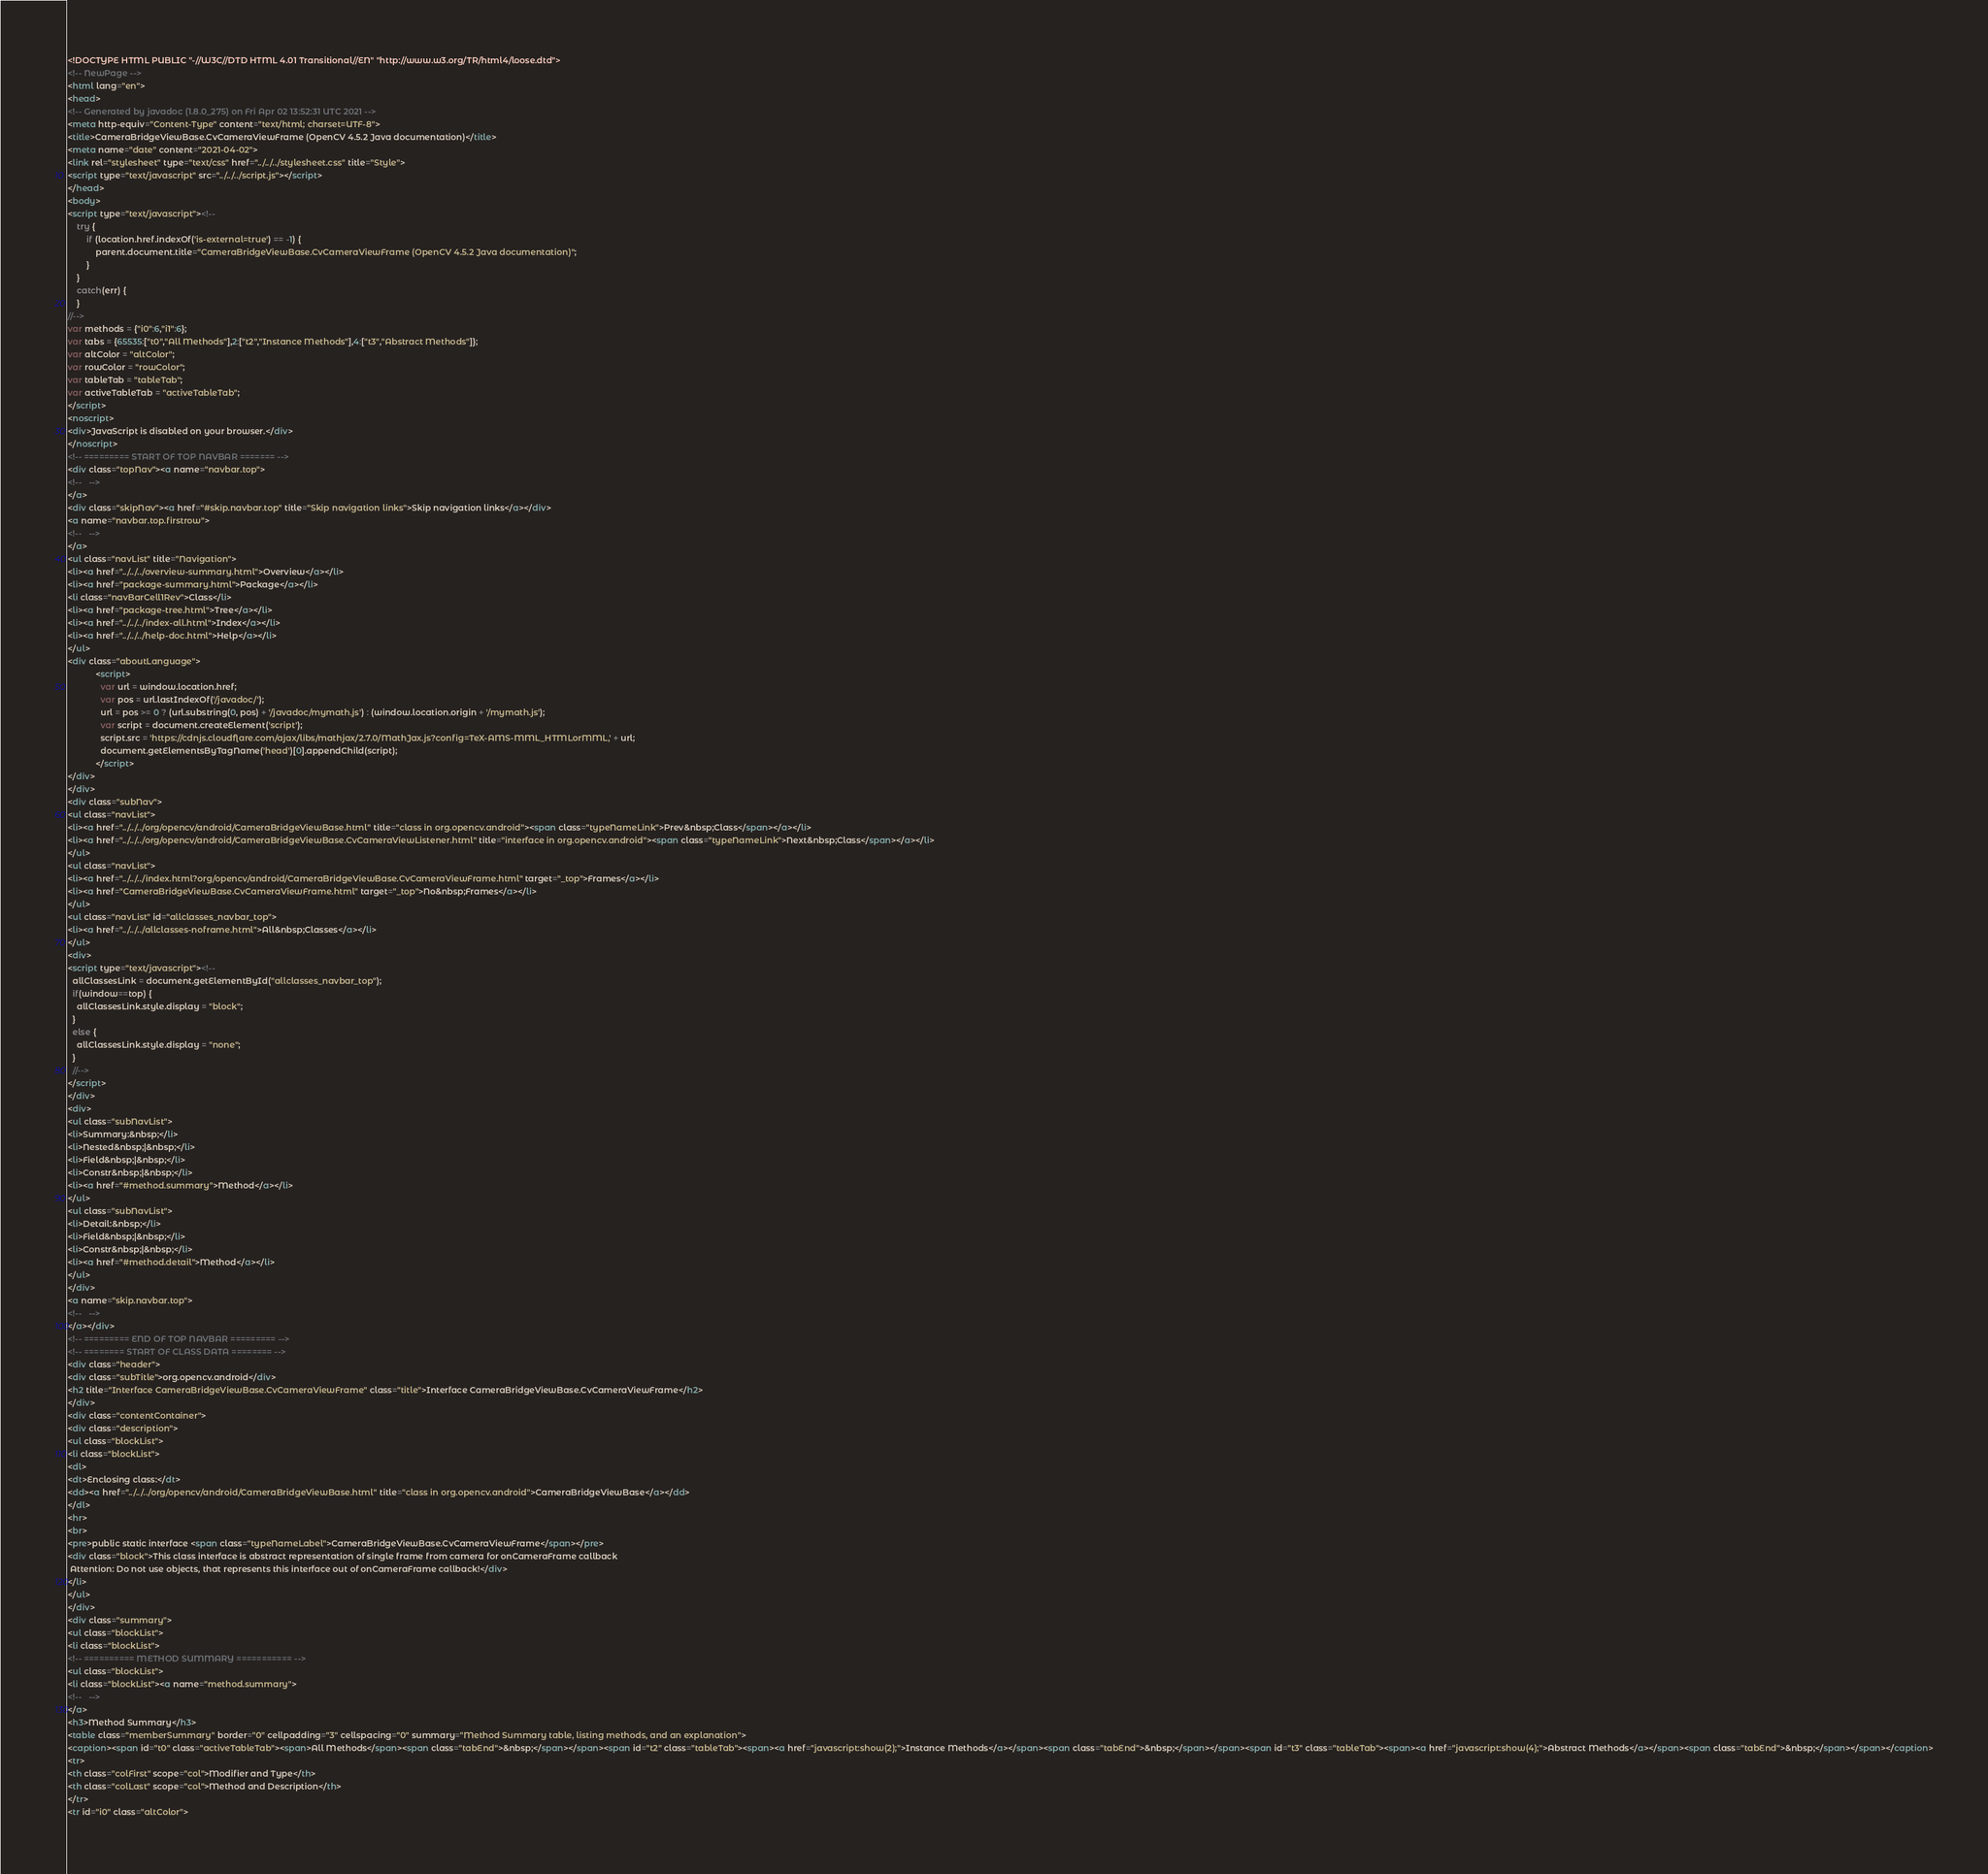<code> <loc_0><loc_0><loc_500><loc_500><_HTML_><!DOCTYPE HTML PUBLIC "-//W3C//DTD HTML 4.01 Transitional//EN" "http://www.w3.org/TR/html4/loose.dtd">
<!-- NewPage -->
<html lang="en">
<head>
<!-- Generated by javadoc (1.8.0_275) on Fri Apr 02 13:52:31 UTC 2021 -->
<meta http-equiv="Content-Type" content="text/html; charset=UTF-8">
<title>CameraBridgeViewBase.CvCameraViewFrame (OpenCV 4.5.2 Java documentation)</title>
<meta name="date" content="2021-04-02">
<link rel="stylesheet" type="text/css" href="../../../stylesheet.css" title="Style">
<script type="text/javascript" src="../../../script.js"></script>
</head>
<body>
<script type="text/javascript"><!--
    try {
        if (location.href.indexOf('is-external=true') == -1) {
            parent.document.title="CameraBridgeViewBase.CvCameraViewFrame (OpenCV 4.5.2 Java documentation)";
        }
    }
    catch(err) {
    }
//-->
var methods = {"i0":6,"i1":6};
var tabs = {65535:["t0","All Methods"],2:["t2","Instance Methods"],4:["t3","Abstract Methods"]};
var altColor = "altColor";
var rowColor = "rowColor";
var tableTab = "tableTab";
var activeTableTab = "activeTableTab";
</script>
<noscript>
<div>JavaScript is disabled on your browser.</div>
</noscript>
<!-- ========= START OF TOP NAVBAR ======= -->
<div class="topNav"><a name="navbar.top">
<!--   -->
</a>
<div class="skipNav"><a href="#skip.navbar.top" title="Skip navigation links">Skip navigation links</a></div>
<a name="navbar.top.firstrow">
<!--   -->
</a>
<ul class="navList" title="Navigation">
<li><a href="../../../overview-summary.html">Overview</a></li>
<li><a href="package-summary.html">Package</a></li>
<li class="navBarCell1Rev">Class</li>
<li><a href="package-tree.html">Tree</a></li>
<li><a href="../../../index-all.html">Index</a></li>
<li><a href="../../../help-doc.html">Help</a></li>
</ul>
<div class="aboutLanguage">
            <script>
              var url = window.location.href;
              var pos = url.lastIndexOf('/javadoc/');
              url = pos >= 0 ? (url.substring(0, pos) + '/javadoc/mymath.js') : (window.location.origin + '/mymath.js');
              var script = document.createElement('script');
              script.src = 'https://cdnjs.cloudflare.com/ajax/libs/mathjax/2.7.0/MathJax.js?config=TeX-AMS-MML_HTMLorMML,' + url;
              document.getElementsByTagName('head')[0].appendChild(script);
            </script>
</div>
</div>
<div class="subNav">
<ul class="navList">
<li><a href="../../../org/opencv/android/CameraBridgeViewBase.html" title="class in org.opencv.android"><span class="typeNameLink">Prev&nbsp;Class</span></a></li>
<li><a href="../../../org/opencv/android/CameraBridgeViewBase.CvCameraViewListener.html" title="interface in org.opencv.android"><span class="typeNameLink">Next&nbsp;Class</span></a></li>
</ul>
<ul class="navList">
<li><a href="../../../index.html?org/opencv/android/CameraBridgeViewBase.CvCameraViewFrame.html" target="_top">Frames</a></li>
<li><a href="CameraBridgeViewBase.CvCameraViewFrame.html" target="_top">No&nbsp;Frames</a></li>
</ul>
<ul class="navList" id="allclasses_navbar_top">
<li><a href="../../../allclasses-noframe.html">All&nbsp;Classes</a></li>
</ul>
<div>
<script type="text/javascript"><!--
  allClassesLink = document.getElementById("allclasses_navbar_top");
  if(window==top) {
    allClassesLink.style.display = "block";
  }
  else {
    allClassesLink.style.display = "none";
  }
  //-->
</script>
</div>
<div>
<ul class="subNavList">
<li>Summary:&nbsp;</li>
<li>Nested&nbsp;|&nbsp;</li>
<li>Field&nbsp;|&nbsp;</li>
<li>Constr&nbsp;|&nbsp;</li>
<li><a href="#method.summary">Method</a></li>
</ul>
<ul class="subNavList">
<li>Detail:&nbsp;</li>
<li>Field&nbsp;|&nbsp;</li>
<li>Constr&nbsp;|&nbsp;</li>
<li><a href="#method.detail">Method</a></li>
</ul>
</div>
<a name="skip.navbar.top">
<!--   -->
</a></div>
<!-- ========= END OF TOP NAVBAR ========= -->
<!-- ======== START OF CLASS DATA ======== -->
<div class="header">
<div class="subTitle">org.opencv.android</div>
<h2 title="Interface CameraBridgeViewBase.CvCameraViewFrame" class="title">Interface CameraBridgeViewBase.CvCameraViewFrame</h2>
</div>
<div class="contentContainer">
<div class="description">
<ul class="blockList">
<li class="blockList">
<dl>
<dt>Enclosing class:</dt>
<dd><a href="../../../org/opencv/android/CameraBridgeViewBase.html" title="class in org.opencv.android">CameraBridgeViewBase</a></dd>
</dl>
<hr>
<br>
<pre>public static interface <span class="typeNameLabel">CameraBridgeViewBase.CvCameraViewFrame</span></pre>
<div class="block">This class interface is abstract representation of single frame from camera for onCameraFrame callback
 Attention: Do not use objects, that represents this interface out of onCameraFrame callback!</div>
</li>
</ul>
</div>
<div class="summary">
<ul class="blockList">
<li class="blockList">
<!-- ========== METHOD SUMMARY =========== -->
<ul class="blockList">
<li class="blockList"><a name="method.summary">
<!--   -->
</a>
<h3>Method Summary</h3>
<table class="memberSummary" border="0" cellpadding="3" cellspacing="0" summary="Method Summary table, listing methods, and an explanation">
<caption><span id="t0" class="activeTableTab"><span>All Methods</span><span class="tabEnd">&nbsp;</span></span><span id="t2" class="tableTab"><span><a href="javascript:show(2);">Instance Methods</a></span><span class="tabEnd">&nbsp;</span></span><span id="t3" class="tableTab"><span><a href="javascript:show(4);">Abstract Methods</a></span><span class="tabEnd">&nbsp;</span></span></caption>
<tr>
<th class="colFirst" scope="col">Modifier and Type</th>
<th class="colLast" scope="col">Method and Description</th>
</tr>
<tr id="i0" class="altColor"></code> 